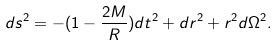<formula> <loc_0><loc_0><loc_500><loc_500>d s ^ { 2 } = - ( 1 - \frac { 2 M } { R } ) d t ^ { 2 } + d r ^ { 2 } + r ^ { 2 } d \Omega ^ { 2 } .</formula> 